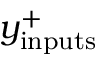<formula> <loc_0><loc_0><loc_500><loc_500>y _ { i n p u t s } ^ { + }</formula> 